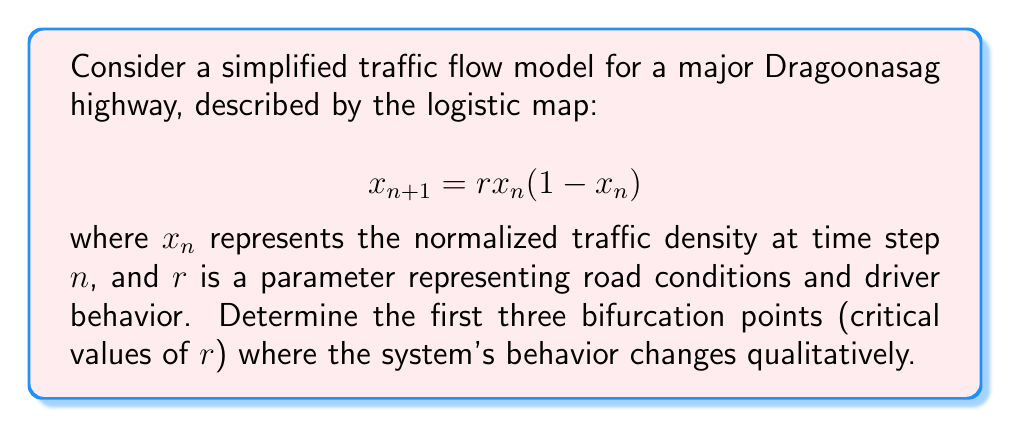Can you solve this math problem? To find the bifurcation points, we need to analyze the stability of the fixed points and their period-doubling behavior:

1. Find the fixed points:
   Set $x_{n+1} = x_n = x^*$
   $$x^* = rx^*(1-x^*)$$
   Solving this equation gives two fixed points:
   $x^*_1 = 0$ and $x^*_2 = 1 - \frac{1}{r}$

2. Analyze stability of $x^*_2$:
   The derivative of the map is $f'(x) = r(1-2x)$
   At $x^*_2$, $f'(x^*_2) = 2 - r$

3. First bifurcation point (loss of stability of $x^*_2$):
   Occurs when $|f'(x^*_2)| = 1$
   $|2 - r| = 1$
   Solving this, we get $r_1 = 3$

4. Second bifurcation point (period-2 cycle loses stability):
   Occurs at approximately $r_2 \approx 3.449$

5. Third bifurcation point (period-4 cycle appears):
   Occurs at approximately $r_3 \approx 3.544$

These values can be obtained through numerical analysis or by consulting the well-known bifurcation diagram of the logistic map.
Answer: $r_1 = 3$, $r_2 \approx 3.449$, $r_3 \approx 3.544$ 